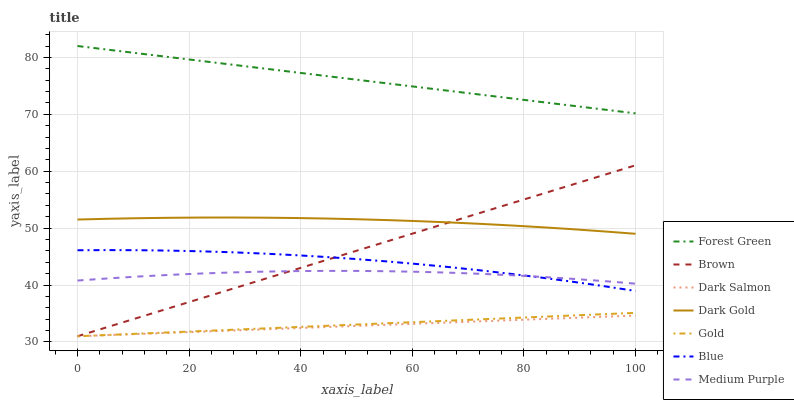Does Brown have the minimum area under the curve?
Answer yes or no. No. Does Brown have the maximum area under the curve?
Answer yes or no. No. Is Brown the smoothest?
Answer yes or no. No. Is Brown the roughest?
Answer yes or no. No. Does Dark Gold have the lowest value?
Answer yes or no. No. Does Brown have the highest value?
Answer yes or no. No. Is Medium Purple less than Dark Gold?
Answer yes or no. Yes. Is Blue greater than Gold?
Answer yes or no. Yes. Does Medium Purple intersect Dark Gold?
Answer yes or no. No. 